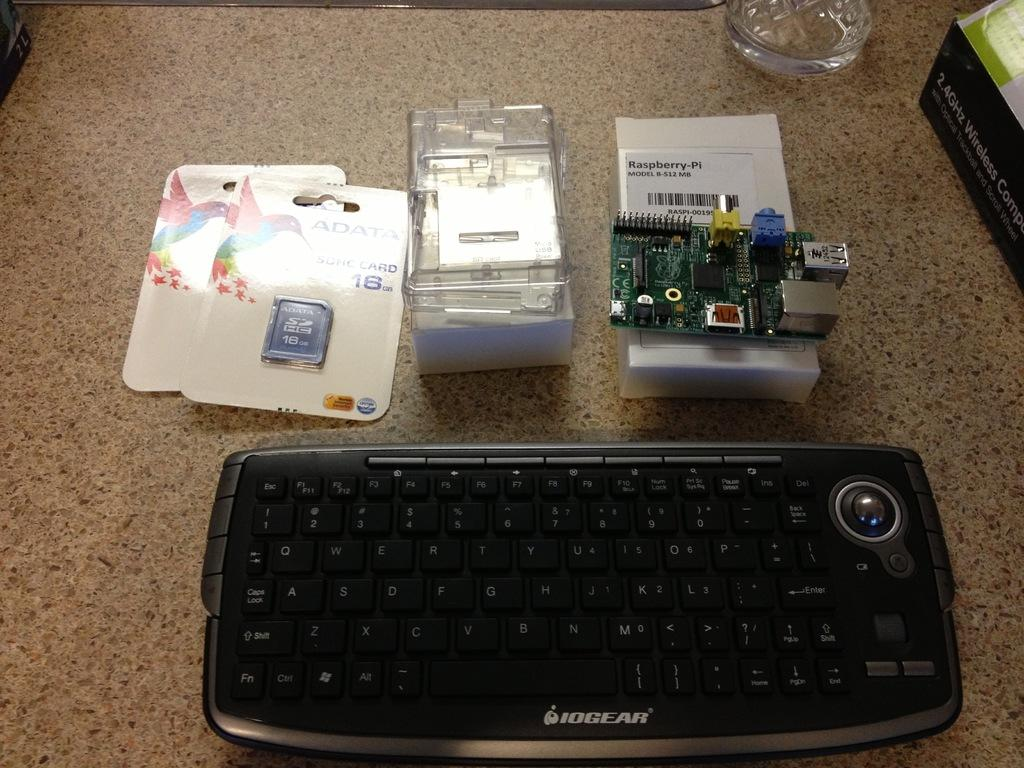What type of objects can be seen stacked in the image? There are boxes in the image. What electronic device is visible in the image? There is a keyboard in the image. What else can be found on the floor in the image? There are other objects on the floor in the image. Can you see a goose playing with a pail in the image? No, there is no goose or pail present in the image. 